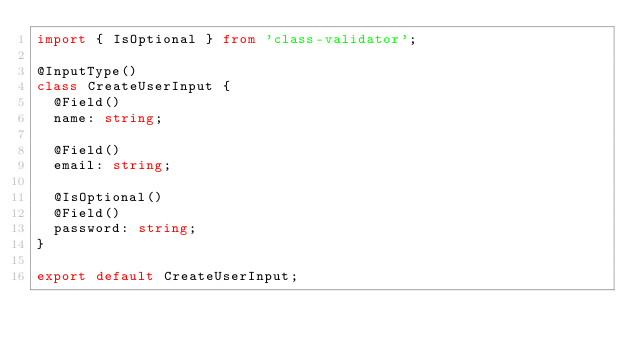<code> <loc_0><loc_0><loc_500><loc_500><_TypeScript_>import { IsOptional } from 'class-validator';

@InputType()
class CreateUserInput {
  @Field()
  name: string;

  @Field()
  email: string;

  @IsOptional()
  @Field()
  password: string;
}

export default CreateUserInput;
</code> 